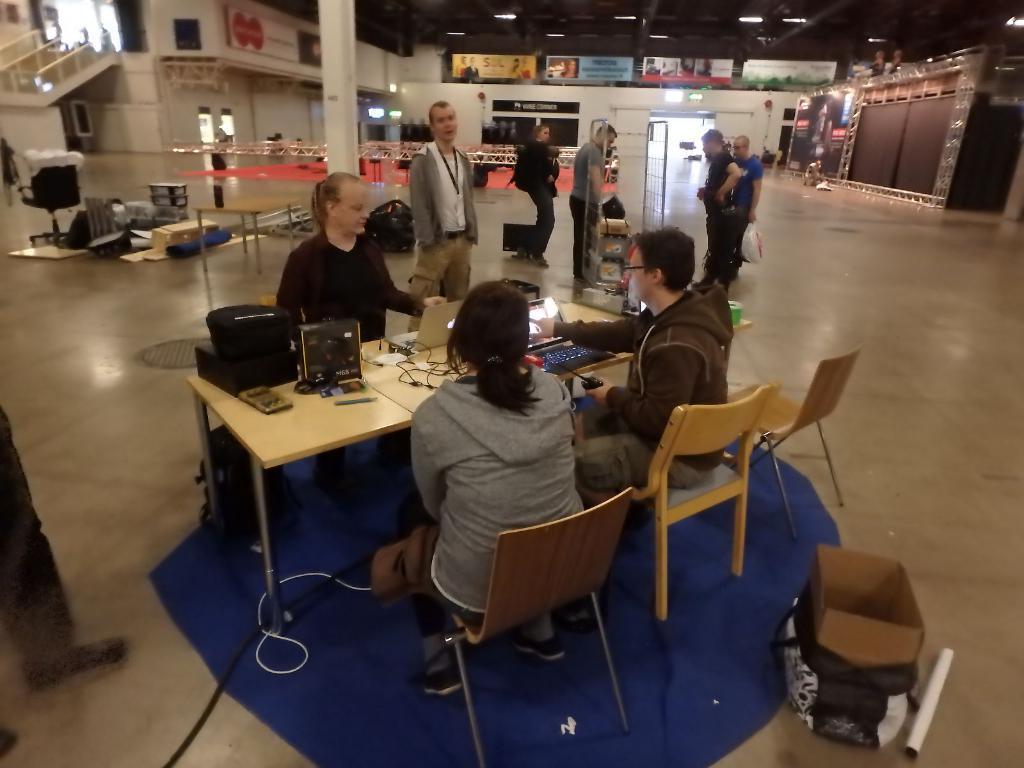Could you give a brief overview of what you see in this image? There is a woman sitting on the chair and there is a table in which there is a laptop and different types of wires and there is a tab also on the table and the man sitting on the chair is operating the tab and on the top right corner we can see a man holding a cover in his hand and on the bottom right corner we can see a bag and cardboard and on the top we can see a ceiling which has a lights in it. On the left side we can see a pillar,on the left corner we can see a hoarding. There are people standing on the floor ,there is a light in the top left corner and there is a staircase on top left corner and their are different things on table. 